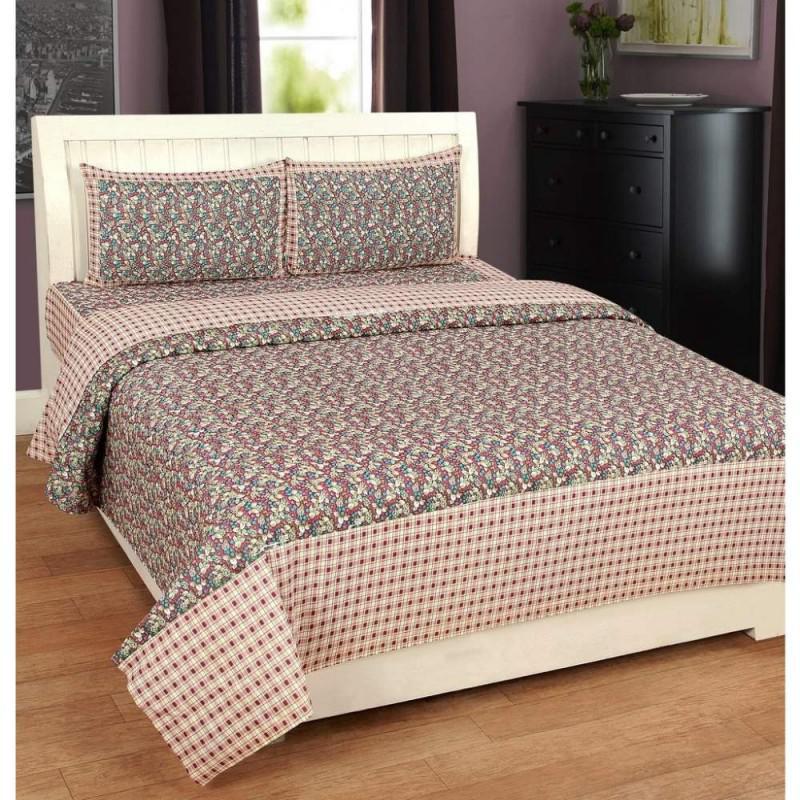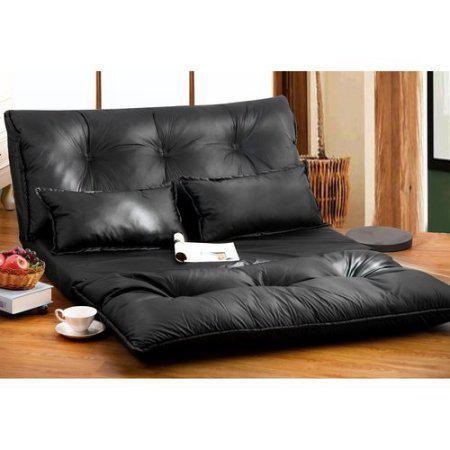The first image is the image on the left, the second image is the image on the right. Assess this claim about the two images: "The left and right image contains the same number of pillow place on the bed.". Correct or not? Answer yes or no. Yes. The first image is the image on the left, the second image is the image on the right. For the images displayed, is the sentence "The right image shows pillows on a sofa-shaped dark bed that is angled facing rightward." factually correct? Answer yes or no. Yes. 